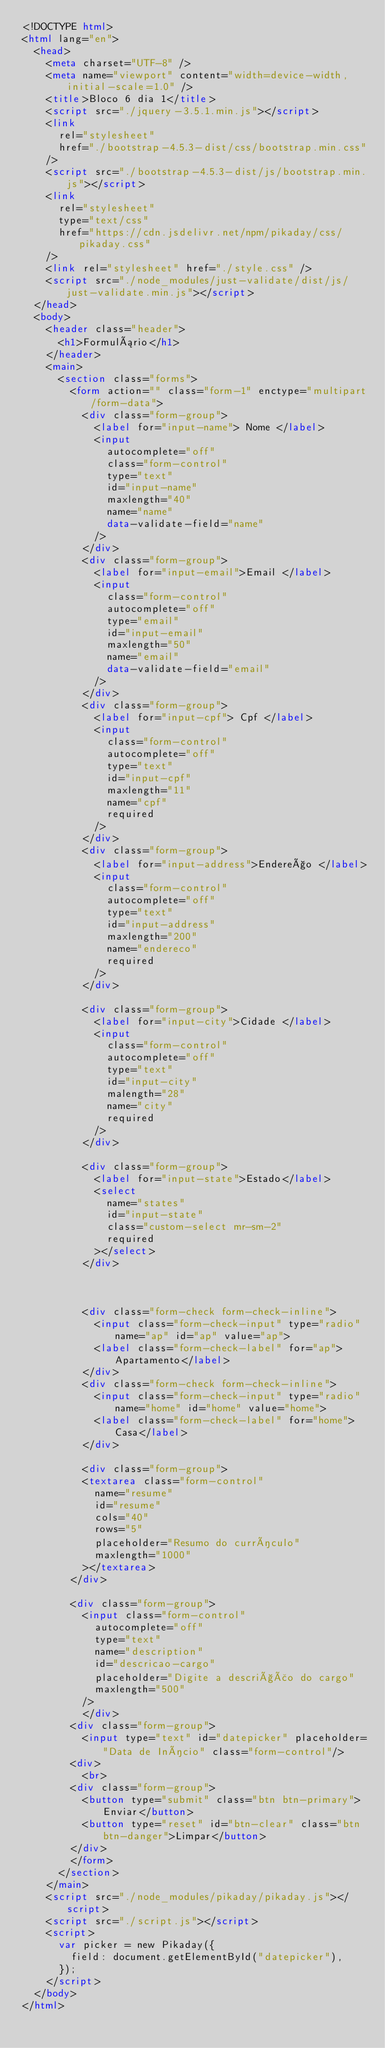Convert code to text. <code><loc_0><loc_0><loc_500><loc_500><_HTML_><!DOCTYPE html>
<html lang="en">
  <head>
    <meta charset="UTF-8" />
    <meta name="viewport" content="width=device-width, initial-scale=1.0" />
    <title>Bloco 6 dia 1</title>
    <script src="./jquery-3.5.1.min.js"></script>
    <link
      rel="stylesheet"
      href="./bootstrap-4.5.3-dist/css/bootstrap.min.css"
    />
    <script src="./bootstrap-4.5.3-dist/js/bootstrap.min.js"></script>
    <link
      rel="stylesheet"
      type="text/css"
      href="https://cdn.jsdelivr.net/npm/pikaday/css/pikaday.css"
    />
    <link rel="stylesheet" href="./style.css" />
    <script src="./node_modules/just-validate/dist/js/just-validate.min.js"></script>
  </head>
  <body>
    <header class="header">
      <h1>Formulário</h1>
    </header>
    <main>
      <section class="forms">
        <form action="" class="form-1" enctype="multipart/form-data">
          <div class="form-group">
            <label for="input-name"> Nome </label>
            <input
              autocomplete="off"
              class="form-control"
              type="text"
              id="input-name"
              maxlength="40"
              name="name"
              data-validate-field="name"
            />
          </div>
          <div class="form-group">
            <label for="input-email">Email </label>
            <input
              class="form-control"
              autocomplete="off"
              type="email"
              id="input-email"
              maxlength="50"
              name="email"
              data-validate-field="email"
            />
          </div>
          <div class="form-group">
            <label for="input-cpf"> Cpf </label>
            <input
              class="form-control"
              autocomplete="off"
              type="text"
              id="input-cpf"
              maxlength="11"
              name="cpf"
              required
            />
          </div>
          <div class="form-group">
            <label for="input-address">Endereço </label>
            <input
              class="form-control"
              autocomplete="off"
              type="text"
              id="input-address"
              maxlength="200"
              name="endereco"
              required
            />
          </div>

          <div class="form-group">
            <label for="input-city">Cidade </label>
            <input
              class="form-control"
              autocomplete="off"
              type="text"
              id="input-city"
              malength="28"
              name="city"
              required
            />
          </div>

          <div class="form-group">
            <label for="input-state">Estado</label>
            <select
              name="states"
              id="input-state"
              class="custom-select mr-sm-2"
              required
            ></select>
          </div>

          

          <div class="form-check form-check-inline">
            <input class="form-check-input" type="radio" name="ap" id="ap" value="ap">
            <label class="form-check-label" for="ap">Apartamento</label>
          </div>
          <div class="form-check form-check-inline">
            <input class="form-check-input" type="radio" name="home" id="home" value="home">
            <label class="form-check-label" for="home">Casa</label>
          </div>

          <div class="form-group">
          <textarea class="form-control"
            name="resume"
            id="resume"
            cols="40"
            rows="5"
            placeholder="Resumo do currículo"
            maxlength="1000"
          ></textarea>
        </div>

        <div class="form-group">
          <input class="form-control"
            autocomplete="off"
            type="text"
            name="description"
            id="descricao-cargo"
            placeholder="Digite a descrição do cargo"
            maxlength="500"
          />
          </div>
        <div class="form-group">
          <input type="text" id="datepicker" placeholder="Data de Início" class="form-control"/>
        <div>
          <br>
        <div class="form-group">
          <button type="submit" class="btn btn-primary">Enviar</button>
          <button type="reset" id="btn-clear" class="btn btn-danger">Limpar</button>
        </div>
        </form>
      </section>
    </main>
    <script src="./node_modules/pikaday/pikaday.js"></script>
    <script src="./script.js"></script>
    <script>
      var picker = new Pikaday({
        field: document.getElementById("datepicker"),
      });
    </script>
  </body>
</html>
</code> 